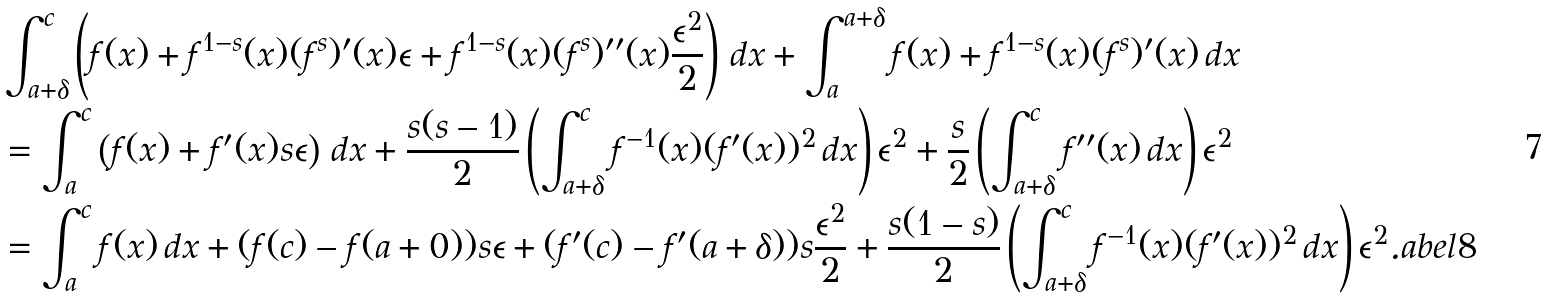<formula> <loc_0><loc_0><loc_500><loc_500>& \int _ { a + \delta } ^ { c } \left ( f ( x ) + f ^ { 1 - s } ( x ) ( f ^ { s } ) ^ { \prime } ( x ) \epsilon + f ^ { 1 - s } ( x ) ( f ^ { s } ) ^ { \prime \prime } ( x ) \frac { \epsilon ^ { 2 } } { 2 } \right ) \, d x + \int _ { a } ^ { a + \delta } f ( x ) + f ^ { 1 - s } ( x ) ( f ^ { s } ) ^ { \prime } ( x ) \, d x \\ & = \int _ { a } ^ { c } \left ( f ( x ) + f ^ { \prime } ( x ) s \epsilon \right ) \, d x + \frac { s ( s - 1 ) } { 2 } \left ( \int _ { a + \delta } ^ { c } f ^ { - 1 } ( x ) ( f ^ { \prime } ( x ) ) ^ { 2 } \, d x \right ) \epsilon ^ { 2 } + \frac { s } { 2 } \left ( \int _ { a + \delta } ^ { c } f ^ { \prime \prime } ( x ) \, d x \right ) \epsilon ^ { 2 } \\ & = \int _ { a } ^ { c } f ( x ) \, d x + ( f ( c ) - f ( a + 0 ) ) s \epsilon + ( f ^ { \prime } ( c ) - f ^ { \prime } ( a + \delta ) ) s \frac { \epsilon ^ { 2 } } { 2 } + \frac { s ( 1 - s ) } { 2 } \left ( \int _ { a + \delta } ^ { c } f ^ { - 1 } ( x ) ( f ^ { \prime } ( x ) ) ^ { 2 } \, d x \right ) \epsilon ^ { 2 } . \L a b e l { 8 }</formula> 